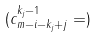Convert formula to latex. <formula><loc_0><loc_0><loc_500><loc_500>( c ^ { k _ { j } - 1 } _ { m - i - k _ { j } + j } = )</formula> 